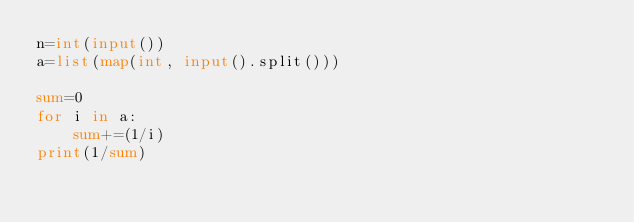Convert code to text. <code><loc_0><loc_0><loc_500><loc_500><_Python_>n=int(input())
a=list(map(int, input().split()))

sum=0
for i in a:
    sum+=(1/i)
print(1/sum)
</code> 